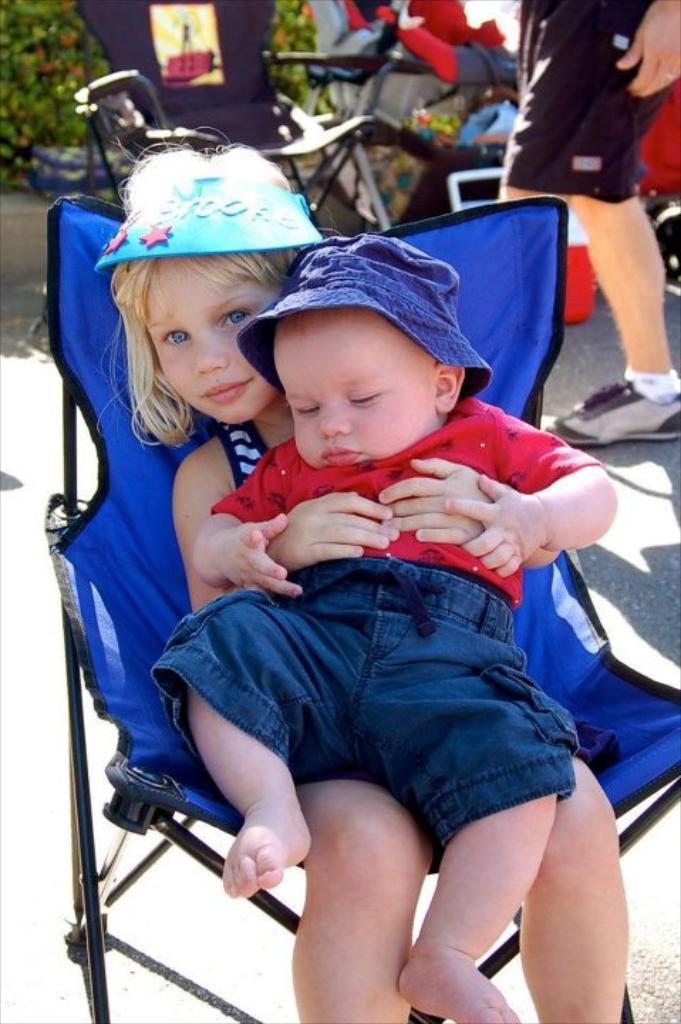How would you summarize this image in a sentence or two? There is a girl sitting on chair and holding a baby. In the background we can see person,chair,plants and objects. 